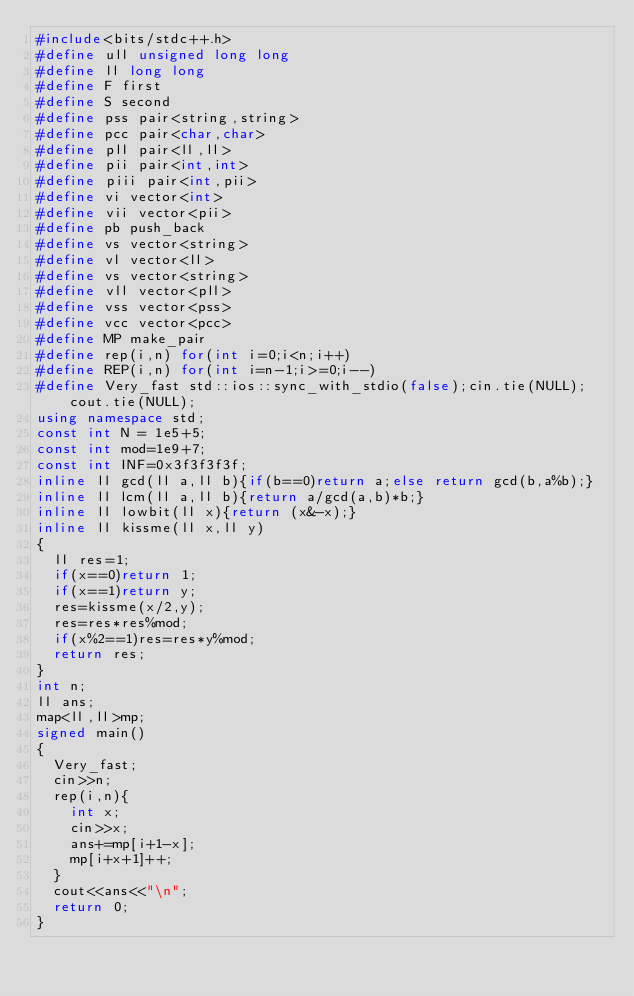<code> <loc_0><loc_0><loc_500><loc_500><_C++_>#include<bits/stdc++.h>
#define ull unsigned long long
#define ll long long
#define F first
#define S second
#define pss pair<string,string>
#define pcc pair<char,char>
#define pll pair<ll,ll>
#define pii pair<int,int>
#define piii pair<int,pii>
#define vi vector<int>
#define vii vector<pii>
#define pb push_back
#define vs vector<string>
#define vl vector<ll>
#define vs vector<string>
#define vll vector<pll>
#define vss vector<pss>
#define vcc vector<pcc>
#define MP make_pair
#define rep(i,n) for(int i=0;i<n;i++)
#define REP(i,n) for(int i=n-1;i>=0;i--)
#define Very_fast std::ios::sync_with_stdio(false);cin.tie(NULL);cout.tie(NULL);
using namespace std;
const int N = 1e5+5;
const int mod=1e9+7;
const int INF=0x3f3f3f3f;
inline ll gcd(ll a,ll b){if(b==0)return a;else return gcd(b,a%b);}
inline ll lcm(ll a,ll b){return a/gcd(a,b)*b;}
inline ll lowbit(ll x){return (x&-x);}
inline ll kissme(ll x,ll y)
{
	ll res=1;
	if(x==0)return 1;
	if(x==1)return y;
	res=kissme(x/2,y);
	res=res*res%mod;
	if(x%2==1)res=res*y%mod;
	return res;
}
int n;
ll ans;
map<ll,ll>mp;
signed main()
{
	Very_fast;
	cin>>n;
	rep(i,n){
		int x;
		cin>>x;
		ans+=mp[i+1-x];
		mp[i+x+1]++;
	}
	cout<<ans<<"\n";
	return 0;
}</code> 